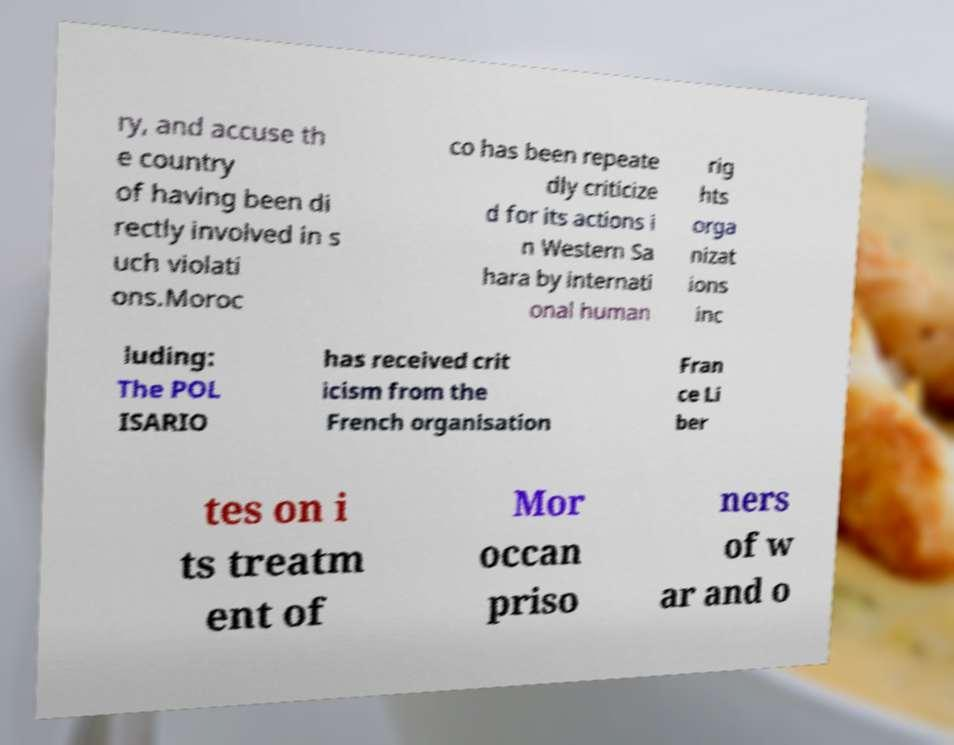Can you read and provide the text displayed in the image?This photo seems to have some interesting text. Can you extract and type it out for me? ry, and accuse th e country of having been di rectly involved in s uch violati ons.Moroc co has been repeate dly criticize d for its actions i n Western Sa hara by internati onal human rig hts orga nizat ions inc luding: The POL ISARIO has received crit icism from the French organisation Fran ce Li ber tes on i ts treatm ent of Mor occan priso ners of w ar and o 